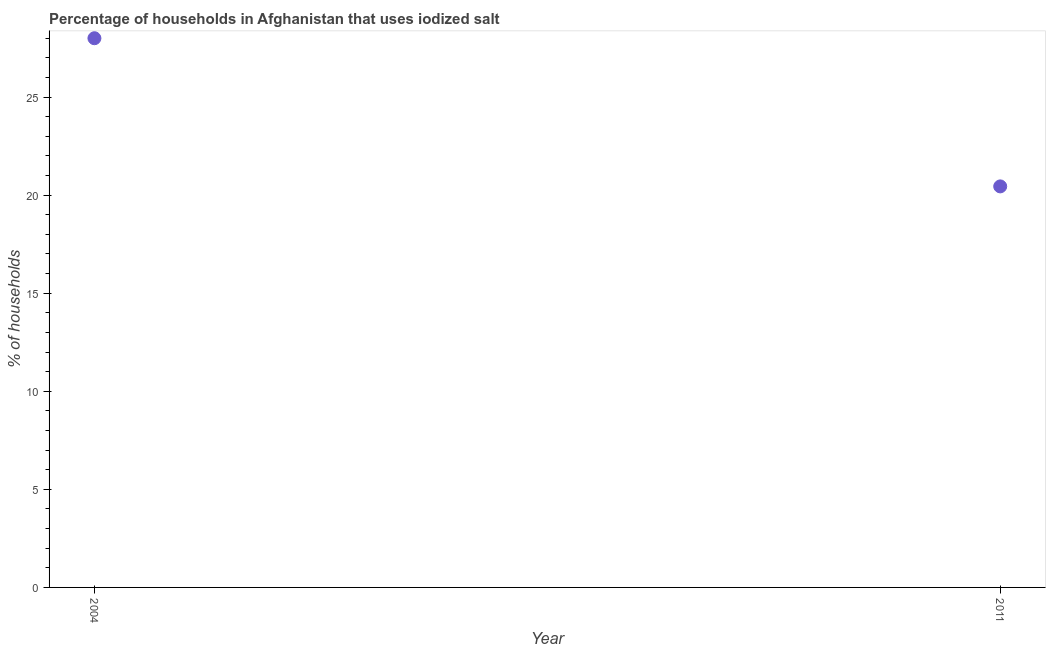Across all years, what is the maximum percentage of households where iodized salt is consumed?
Your answer should be very brief. 28. Across all years, what is the minimum percentage of households where iodized salt is consumed?
Provide a succinct answer. 20.45. What is the sum of the percentage of households where iodized salt is consumed?
Your response must be concise. 48.45. What is the difference between the percentage of households where iodized salt is consumed in 2004 and 2011?
Your answer should be very brief. 7.55. What is the average percentage of households where iodized salt is consumed per year?
Offer a terse response. 24.22. What is the median percentage of households where iodized salt is consumed?
Your answer should be very brief. 24.22. In how many years, is the percentage of households where iodized salt is consumed greater than 27 %?
Keep it short and to the point. 1. What is the ratio of the percentage of households where iodized salt is consumed in 2004 to that in 2011?
Your response must be concise. 1.37. Is the percentage of households where iodized salt is consumed in 2004 less than that in 2011?
Offer a terse response. No. In how many years, is the percentage of households where iodized salt is consumed greater than the average percentage of households where iodized salt is consumed taken over all years?
Provide a succinct answer. 1. Does the percentage of households where iodized salt is consumed monotonically increase over the years?
Offer a terse response. No. How many dotlines are there?
Provide a short and direct response. 1. How many years are there in the graph?
Your answer should be compact. 2. Does the graph contain grids?
Provide a succinct answer. No. What is the title of the graph?
Your answer should be compact. Percentage of households in Afghanistan that uses iodized salt. What is the label or title of the Y-axis?
Offer a terse response. % of households. What is the % of households in 2004?
Make the answer very short. 28. What is the % of households in 2011?
Offer a very short reply. 20.45. What is the difference between the % of households in 2004 and 2011?
Your answer should be compact. 7.55. What is the ratio of the % of households in 2004 to that in 2011?
Offer a terse response. 1.37. 